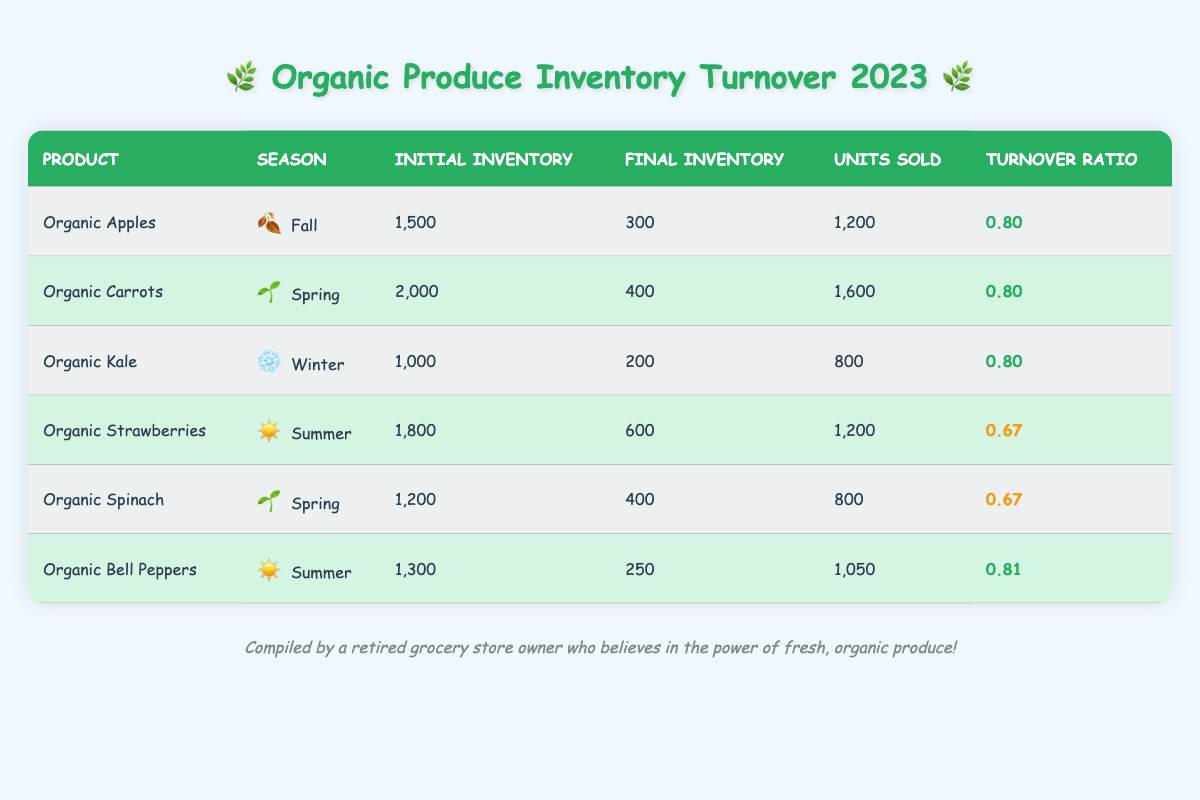What is the turnover ratio for Organic Apples? The table lists the turnover ratio for Organic Apples under the column "Turnover Ratio," which shows a value of 0.80.
Answer: 0.80 How many units of Organic Carrots were sold? The "Units Sold" column for Organic Carrots indicates that 1,600 units were sold.
Answer: 1,600 Is the final inventory for Organic Strawberries higher than that of Organic Spinach? By comparing the "Final Inventory" values, Organic Strawberries has a final inventory of 600, whereas Organic Spinach has a final inventory of 400. Since 600 is greater than 400, the statement is true.
Answer: Yes What is the difference in initial inventory between Organic Bell Peppers and Organic Kale? The initial inventory for Organic Bell Peppers is 1,300 and for Organic Kale, it is 1,000. The difference is calculated as 1,300 - 1,000 = 300.
Answer: 300 Which products have a turnover ratio greater than 0.75? By reviewing the "Turnover Ratio" values in the table, Organic Apples (0.80), Organic Carrots (0.80), Organic Kale (0.80), and Organic Bell Peppers (0.81) all have a turnover ratio greater than 0.75.
Answer: Organic Apples, Organic Carrots, Organic Kale, Organic Bell Peppers What is the average turnover ratio for the products listed in the table? The turnover ratios are 0.80, 0.80, 0.80, 0.67, 0.67, and 0.81. Adding them gives 4.47, and dividing by the number of products (6) results in an average of approximately 0.745.
Answer: 0.745 How many more units of Organic Kale were sold compared to Organic Spinach? Organic Kale sold 800 units while Organic Spinach sold 800 units as well. Therefore, the difference is 800 - 800 = 0.
Answer: 0 Did any organic produce have a final inventory lower than 300? By checking the "Final Inventory" column, only Organic Kale (200) and Organic Bell Peppers (250) have a final inventory lower than 300.
Answer: Yes 